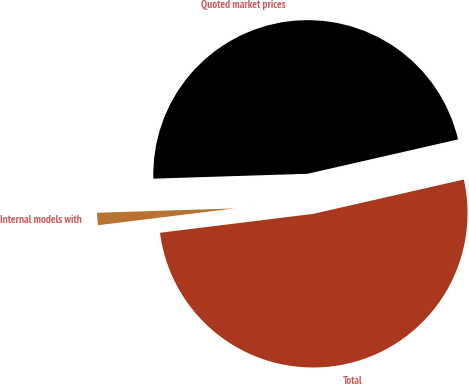Convert chart to OTSL. <chart><loc_0><loc_0><loc_500><loc_500><pie_chart><fcel>Quoted market prices<fcel>Internal models with<fcel>Total<nl><fcel>46.93%<fcel>1.45%<fcel>51.62%<nl></chart> 